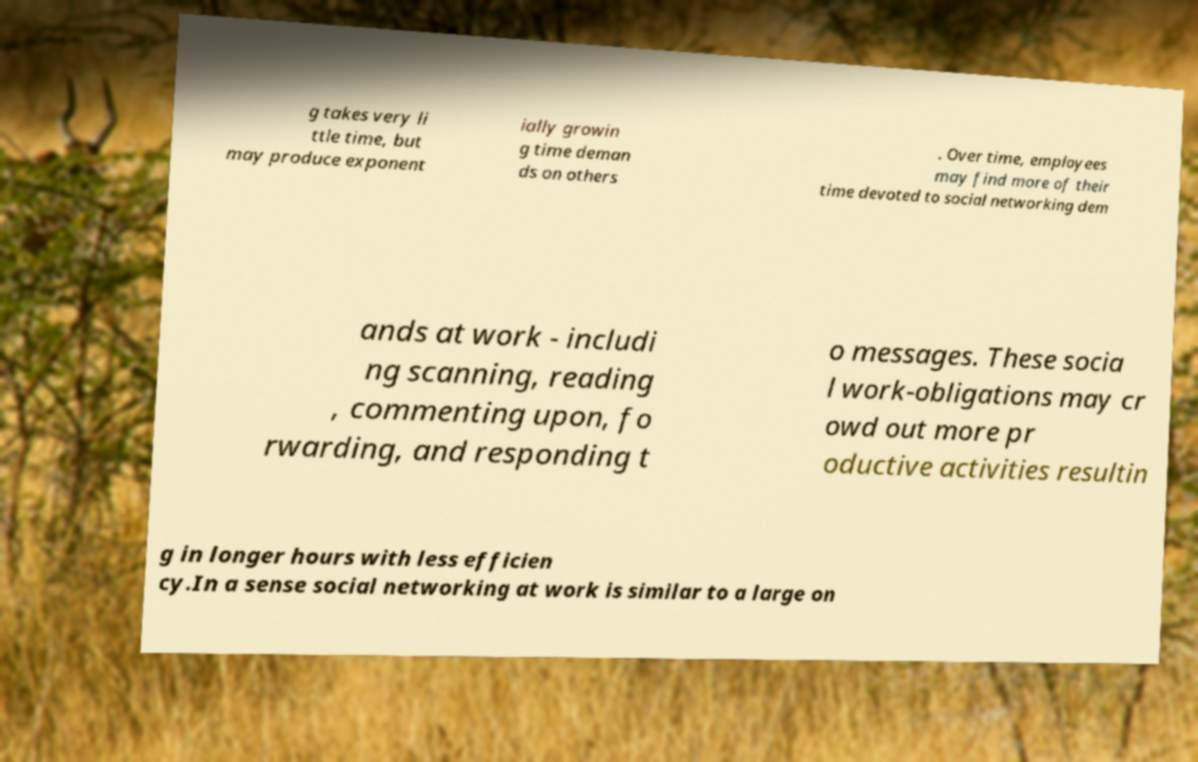What messages or text are displayed in this image? I need them in a readable, typed format. g takes very li ttle time, but may produce exponent ially growin g time deman ds on others . Over time, employees may find more of their time devoted to social networking dem ands at work - includi ng scanning, reading , commenting upon, fo rwarding, and responding t o messages. These socia l work-obligations may cr owd out more pr oductive activities resultin g in longer hours with less efficien cy.In a sense social networking at work is similar to a large on 